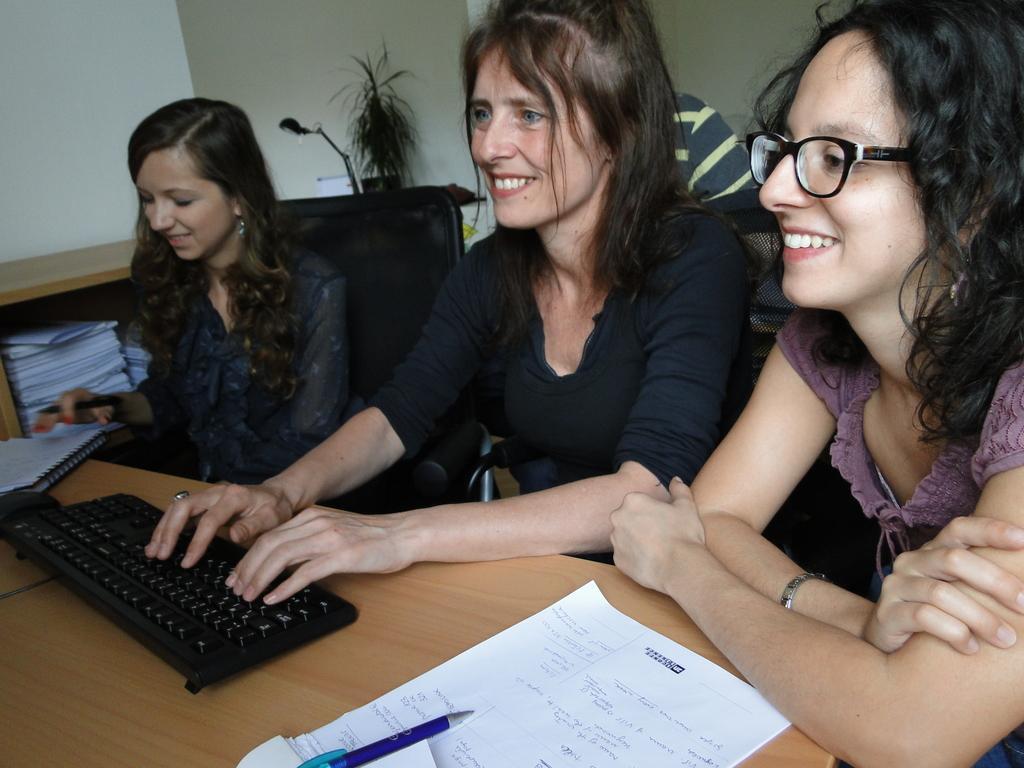In one or two sentences, can you explain what this image depicts? In this image I can see three women are sitting and I can see smile on their faces. I can also see one of them is wearing specs. On this table I can see a white colour paper, a blue colour pen, a black colour keyboard and a book. I can also see white colour things in background. Over there I can see a plant and a lamp. Here on this paper I can see something is written. 